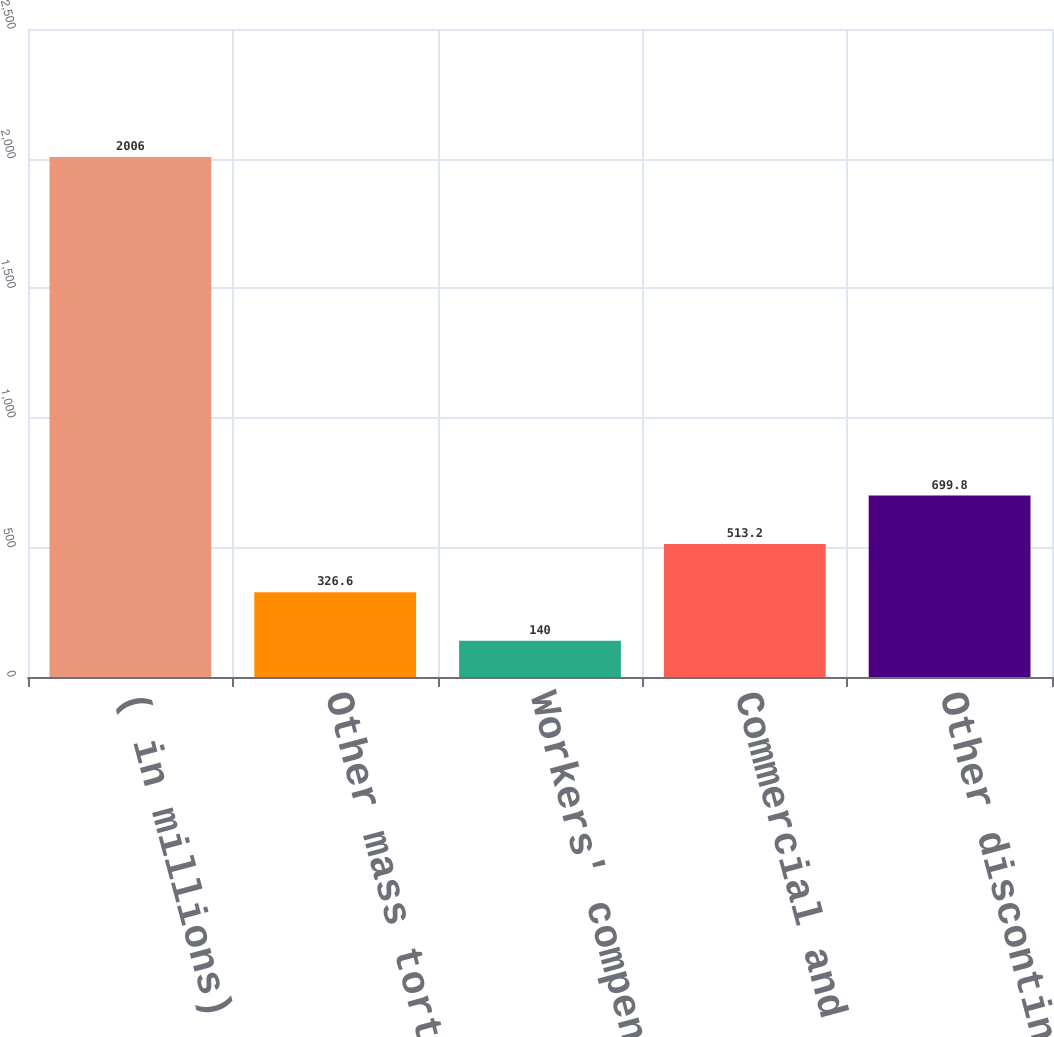Convert chart. <chart><loc_0><loc_0><loc_500><loc_500><bar_chart><fcel>( in millions)<fcel>Other mass torts<fcel>Workers' compensation<fcel>Commercial and other<fcel>Other discontinued lines<nl><fcel>2006<fcel>326.6<fcel>140<fcel>513.2<fcel>699.8<nl></chart> 